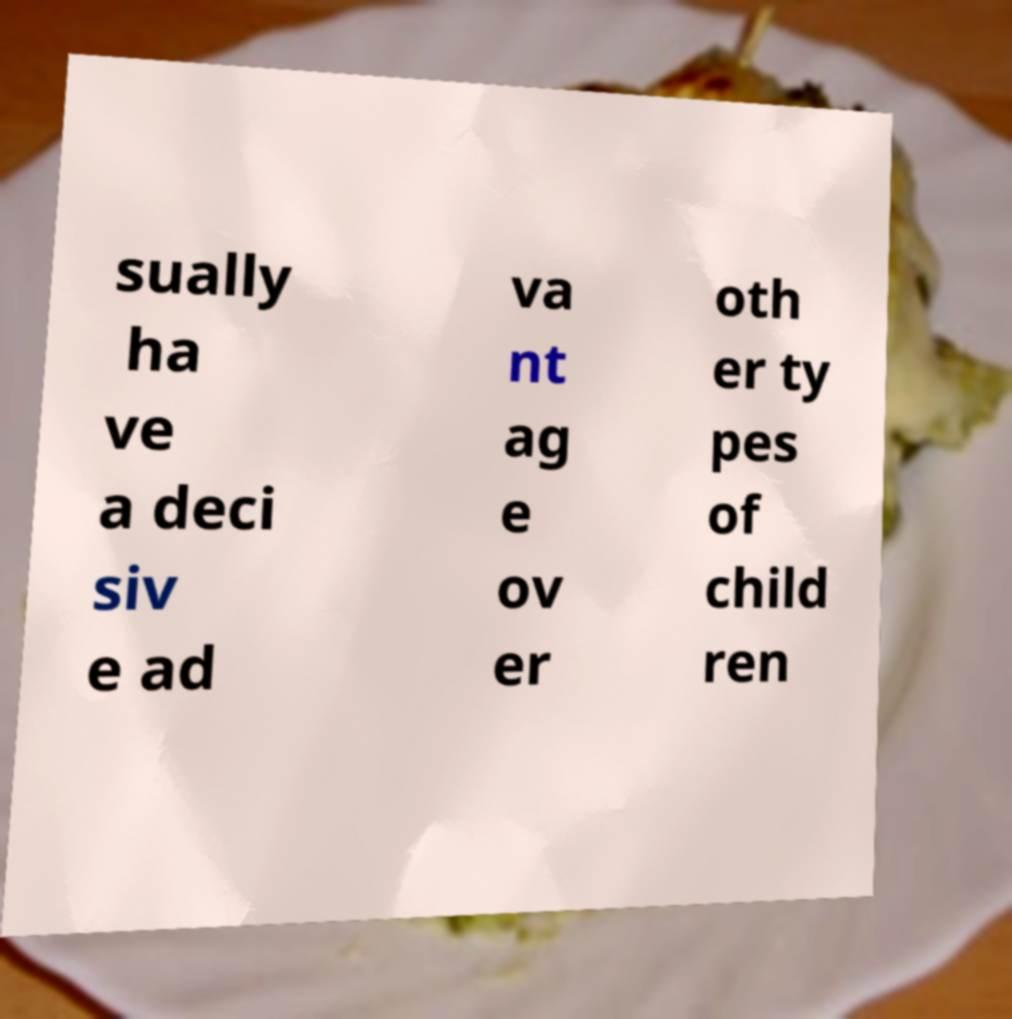There's text embedded in this image that I need extracted. Can you transcribe it verbatim? sually ha ve a deci siv e ad va nt ag e ov er oth er ty pes of child ren 